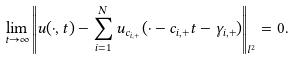Convert formula to latex. <formula><loc_0><loc_0><loc_500><loc_500>\lim _ { t \to \infty } \left \| u ( \cdot , t ) - \sum _ { i = 1 } ^ { N } u _ { c _ { i , + } } ( \cdot - c _ { i , + } t - \gamma _ { i , + } ) \right \| _ { l ^ { 2 } } = 0 .</formula> 